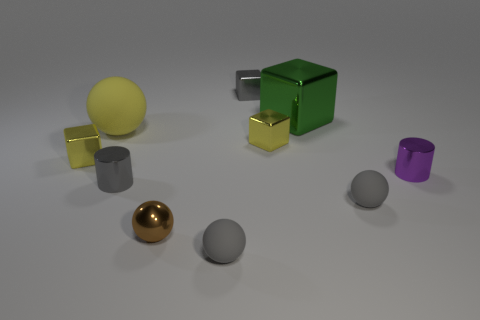The other object that is the same size as the green metallic object is what shape?
Your response must be concise. Sphere. Is there a small purple thing that has the same shape as the large matte object?
Ensure brevity in your answer.  No. What shape is the tiny gray thing that is right of the tiny yellow cube that is right of the small gray cube?
Make the answer very short. Sphere. What is the shape of the tiny brown shiny thing?
Keep it short and to the point. Sphere. What material is the yellow cube on the left side of the rubber ball behind the gray rubber thing that is behind the tiny metallic sphere?
Provide a short and direct response. Metal. How many other objects are there of the same material as the purple object?
Provide a short and direct response. 6. There is a gray metallic thing that is behind the large matte ball; what number of blocks are on the left side of it?
Provide a succinct answer. 1. What number of blocks are either objects or yellow shiny objects?
Give a very brief answer. 4. What color is the metal object that is on the left side of the green block and behind the big ball?
Ensure brevity in your answer.  Gray. Is there any other thing that has the same color as the tiny shiny ball?
Your answer should be very brief. No. 